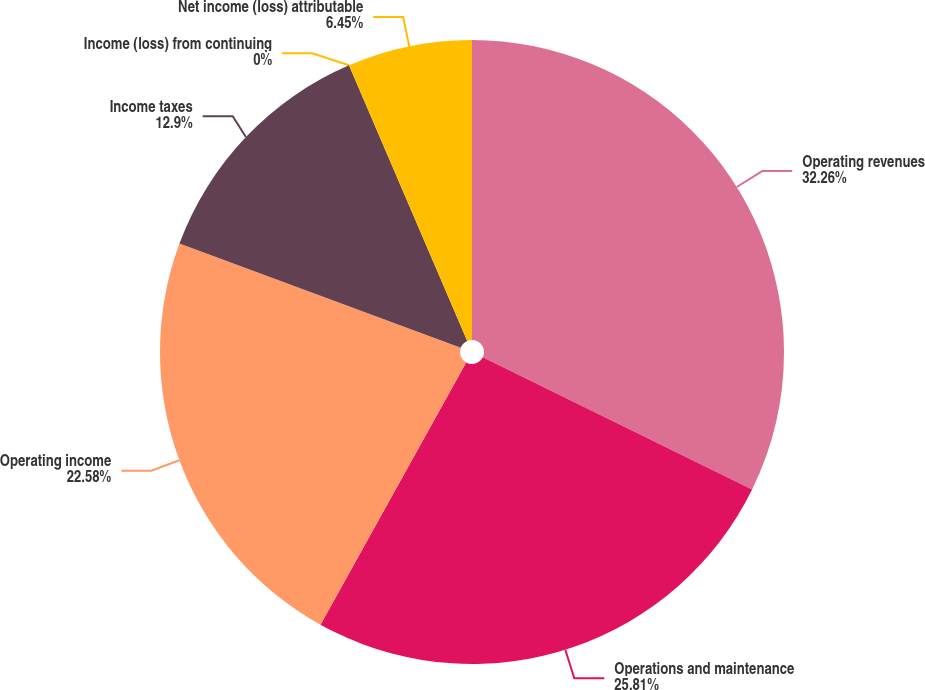<chart> <loc_0><loc_0><loc_500><loc_500><pie_chart><fcel>Operating revenues<fcel>Operations and maintenance<fcel>Operating income<fcel>Income taxes<fcel>Income (loss) from continuing<fcel>Net income (loss) attributable<nl><fcel>32.26%<fcel>25.81%<fcel>22.58%<fcel>12.9%<fcel>0.0%<fcel>6.45%<nl></chart> 